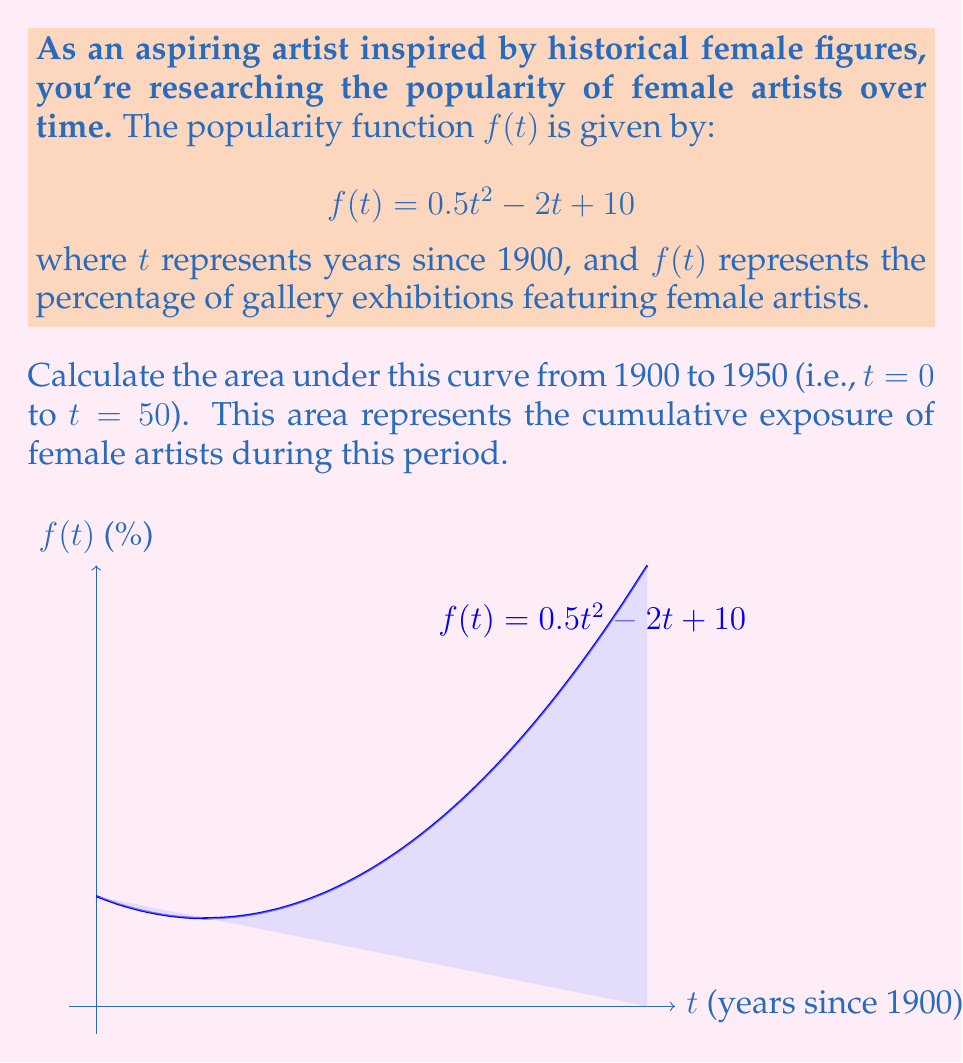Help me with this question. To find the area under the curve, we need to calculate the definite integral of $f(t)$ from $t = 0$ to $t = 50$. Let's approach this step-by-step:

1) The function is $f(t) = 0.5t^2 - 2t + 10$

2) We need to find $\int_0^{50} (0.5t^2 - 2t + 10) dt$

3) Let's integrate each term:
   
   $\int 0.5t^2 dt = \frac{1}{3}t^3$
   $\int -2t dt = -t^2$
   $\int 10 dt = 10t$

4) Now our indefinite integral is:

   $F(t) = \frac{1}{3}t^3 - t^2 + 10t + C$

5) We need to evaluate $F(50) - F(0)$:

   $F(50) = \frac{1}{3}(50^3) - (50^2) + 10(50)$
          $= \frac{125000}{3} - 2500 + 500$
          $= 41666.67 - 2500 + 500$
          $= 39666.67$

   $F(0) = 0$

6) Therefore, the definite integral is:

   $39666.67 - 0 = 39666.67$

This value represents the area under the curve in percentage-years.
Answer: 39666.67 percentage-years 